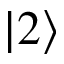Convert formula to latex. <formula><loc_0><loc_0><loc_500><loc_500>| 2 \rangle</formula> 